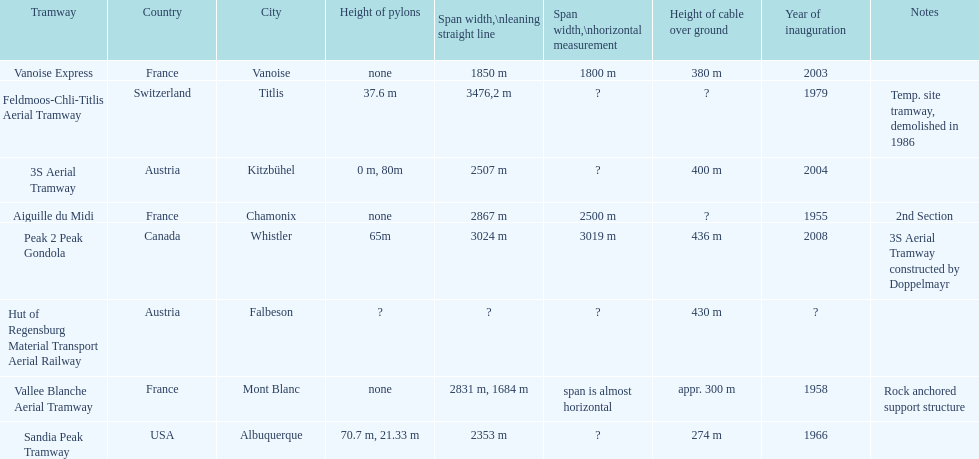Which tramway was built directly before the 3s aeriral tramway? Vanoise Express. 